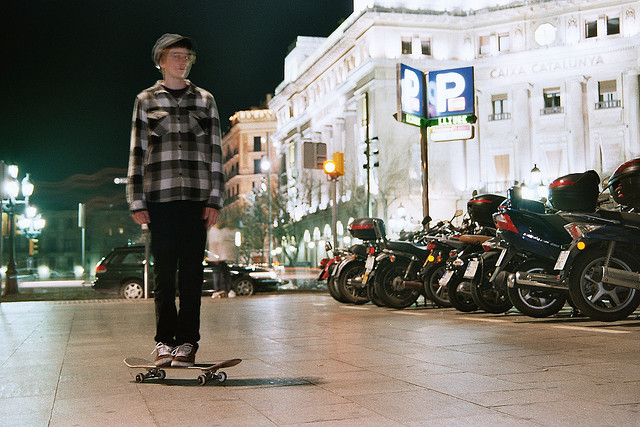Please transcribe the text information in this image. P. P. 